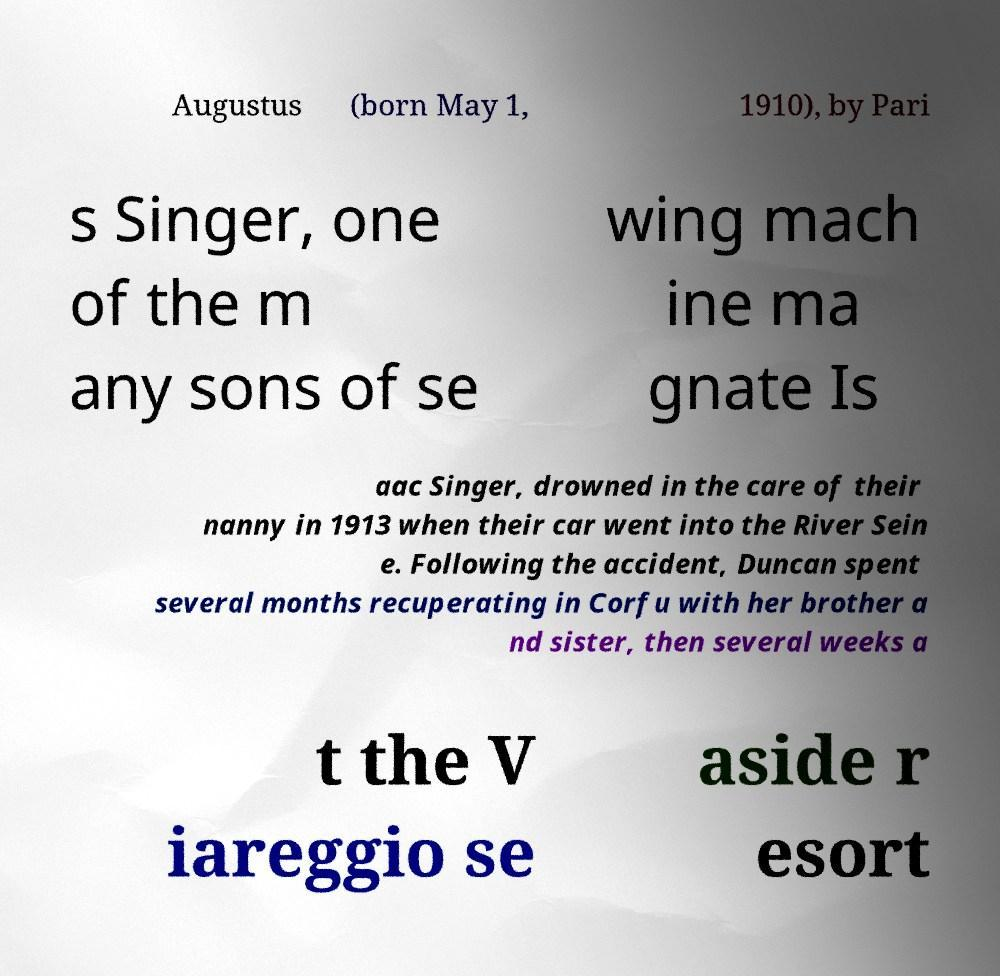There's text embedded in this image that I need extracted. Can you transcribe it verbatim? Augustus (born May 1, 1910), by Pari s Singer, one of the m any sons of se wing mach ine ma gnate Is aac Singer, drowned in the care of their nanny in 1913 when their car went into the River Sein e. Following the accident, Duncan spent several months recuperating in Corfu with her brother a nd sister, then several weeks a t the V iareggio se aside r esort 